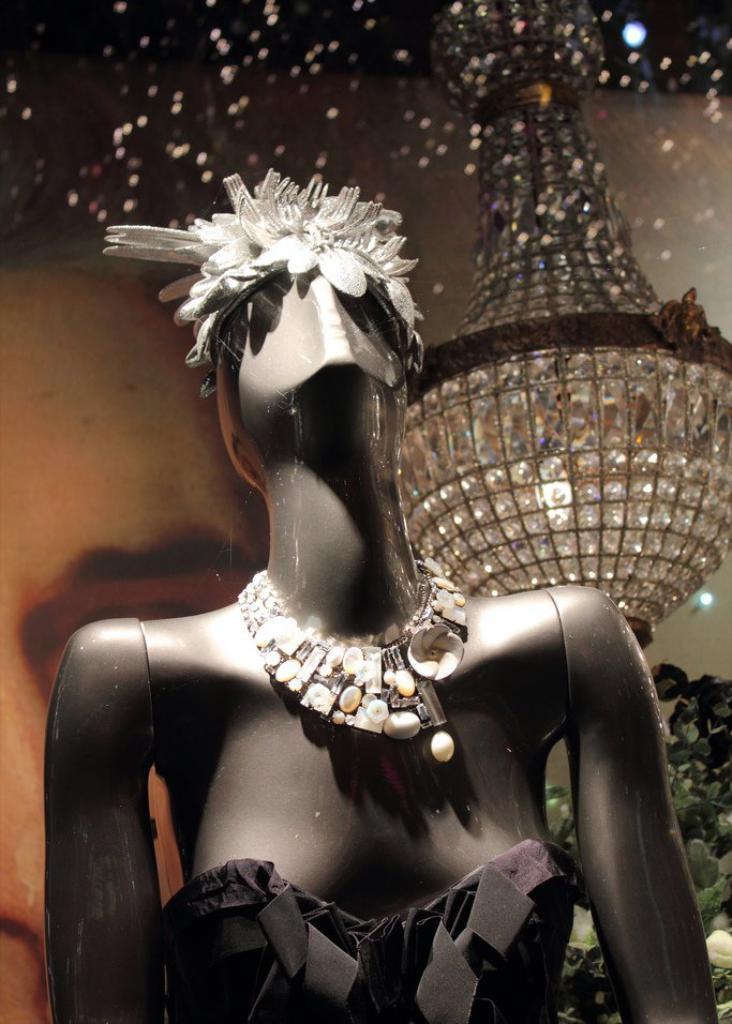How would you summarize this image in a sentence or two? There is a mannequin,it wore a crown and necklace and black dress,behind the mannequin there is a glass and behind the glass a huge light is hanged to the roof. 